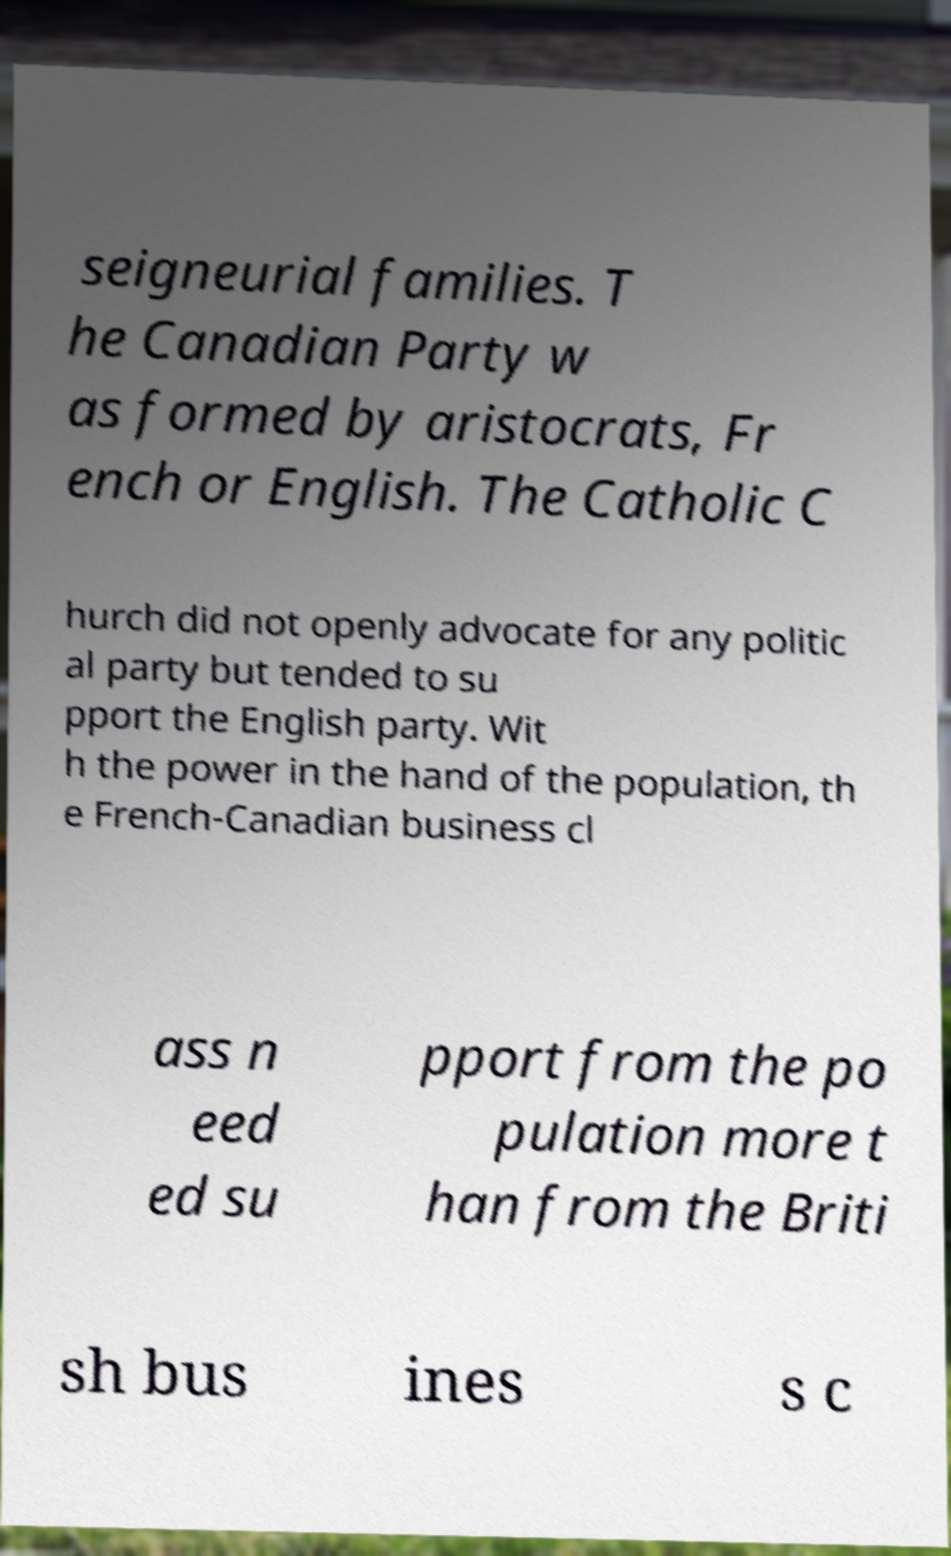Can you read and provide the text displayed in the image?This photo seems to have some interesting text. Can you extract and type it out for me? seigneurial families. T he Canadian Party w as formed by aristocrats, Fr ench or English. The Catholic C hurch did not openly advocate for any politic al party but tended to su pport the English party. Wit h the power in the hand of the population, th e French-Canadian business cl ass n eed ed su pport from the po pulation more t han from the Briti sh bus ines s c 